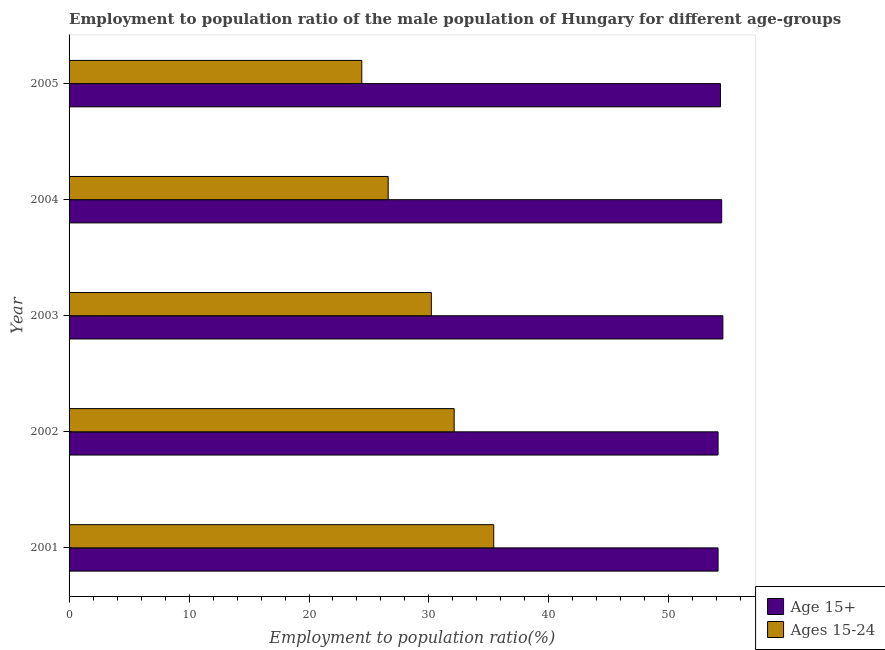How many groups of bars are there?
Make the answer very short. 5. Are the number of bars per tick equal to the number of legend labels?
Keep it short and to the point. Yes. Are the number of bars on each tick of the Y-axis equal?
Make the answer very short. Yes. How many bars are there on the 2nd tick from the top?
Your answer should be compact. 2. What is the label of the 2nd group of bars from the top?
Offer a terse response. 2004. In how many cases, is the number of bars for a given year not equal to the number of legend labels?
Your answer should be very brief. 0. What is the employment to population ratio(age 15-24) in 2004?
Provide a short and direct response. 26.6. Across all years, what is the maximum employment to population ratio(age 15+)?
Provide a succinct answer. 54.5. Across all years, what is the minimum employment to population ratio(age 15-24)?
Give a very brief answer. 24.4. In which year was the employment to population ratio(age 15+) maximum?
Offer a terse response. 2003. What is the total employment to population ratio(age 15+) in the graph?
Offer a terse response. 271.4. What is the difference between the employment to population ratio(age 15+) in 2002 and the employment to population ratio(age 15-24) in 2003?
Your response must be concise. 23.9. What is the average employment to population ratio(age 15-24) per year?
Keep it short and to the point. 29.74. In how many years, is the employment to population ratio(age 15-24) greater than 48 %?
Ensure brevity in your answer.  0. What is the ratio of the employment to population ratio(age 15+) in 2002 to that in 2004?
Provide a short and direct response. 0.99. Is the difference between the employment to population ratio(age 15+) in 2001 and 2004 greater than the difference between the employment to population ratio(age 15-24) in 2001 and 2004?
Keep it short and to the point. No. What is the difference between the highest and the second highest employment to population ratio(age 15+)?
Give a very brief answer. 0.1. What is the difference between the highest and the lowest employment to population ratio(age 15+)?
Offer a terse response. 0.4. In how many years, is the employment to population ratio(age 15-24) greater than the average employment to population ratio(age 15-24) taken over all years?
Offer a terse response. 3. What does the 2nd bar from the top in 2001 represents?
Give a very brief answer. Age 15+. What does the 2nd bar from the bottom in 2002 represents?
Your answer should be compact. Ages 15-24. How many bars are there?
Provide a short and direct response. 10. Are all the bars in the graph horizontal?
Your answer should be very brief. Yes. Where does the legend appear in the graph?
Make the answer very short. Bottom right. How are the legend labels stacked?
Offer a very short reply. Vertical. What is the title of the graph?
Ensure brevity in your answer.  Employment to population ratio of the male population of Hungary for different age-groups. Does "From human activities" appear as one of the legend labels in the graph?
Your answer should be very brief. No. What is the label or title of the X-axis?
Your answer should be very brief. Employment to population ratio(%). What is the Employment to population ratio(%) of Age 15+ in 2001?
Offer a terse response. 54.1. What is the Employment to population ratio(%) of Ages 15-24 in 2001?
Make the answer very short. 35.4. What is the Employment to population ratio(%) in Age 15+ in 2002?
Keep it short and to the point. 54.1. What is the Employment to population ratio(%) in Ages 15-24 in 2002?
Provide a succinct answer. 32.1. What is the Employment to population ratio(%) in Age 15+ in 2003?
Provide a short and direct response. 54.5. What is the Employment to population ratio(%) in Ages 15-24 in 2003?
Your answer should be compact. 30.2. What is the Employment to population ratio(%) of Age 15+ in 2004?
Provide a short and direct response. 54.4. What is the Employment to population ratio(%) of Ages 15-24 in 2004?
Provide a succinct answer. 26.6. What is the Employment to population ratio(%) of Age 15+ in 2005?
Give a very brief answer. 54.3. What is the Employment to population ratio(%) of Ages 15-24 in 2005?
Provide a short and direct response. 24.4. Across all years, what is the maximum Employment to population ratio(%) in Age 15+?
Your answer should be compact. 54.5. Across all years, what is the maximum Employment to population ratio(%) in Ages 15-24?
Your response must be concise. 35.4. Across all years, what is the minimum Employment to population ratio(%) in Age 15+?
Keep it short and to the point. 54.1. Across all years, what is the minimum Employment to population ratio(%) of Ages 15-24?
Offer a very short reply. 24.4. What is the total Employment to population ratio(%) of Age 15+ in the graph?
Ensure brevity in your answer.  271.4. What is the total Employment to population ratio(%) of Ages 15-24 in the graph?
Make the answer very short. 148.7. What is the difference between the Employment to population ratio(%) in Age 15+ in 2001 and that in 2002?
Provide a short and direct response. 0. What is the difference between the Employment to population ratio(%) of Age 15+ in 2001 and that in 2004?
Offer a very short reply. -0.3. What is the difference between the Employment to population ratio(%) in Ages 15-24 in 2001 and that in 2004?
Give a very brief answer. 8.8. What is the difference between the Employment to population ratio(%) in Age 15+ in 2002 and that in 2004?
Give a very brief answer. -0.3. What is the difference between the Employment to population ratio(%) in Ages 15-24 in 2002 and that in 2005?
Make the answer very short. 7.7. What is the difference between the Employment to population ratio(%) of Age 15+ in 2003 and that in 2004?
Provide a succinct answer. 0.1. What is the difference between the Employment to population ratio(%) of Ages 15-24 in 2003 and that in 2004?
Make the answer very short. 3.6. What is the difference between the Employment to population ratio(%) of Age 15+ in 2004 and that in 2005?
Offer a very short reply. 0.1. What is the difference between the Employment to population ratio(%) in Age 15+ in 2001 and the Employment to population ratio(%) in Ages 15-24 in 2002?
Your response must be concise. 22. What is the difference between the Employment to population ratio(%) in Age 15+ in 2001 and the Employment to population ratio(%) in Ages 15-24 in 2003?
Keep it short and to the point. 23.9. What is the difference between the Employment to population ratio(%) in Age 15+ in 2001 and the Employment to population ratio(%) in Ages 15-24 in 2004?
Provide a short and direct response. 27.5. What is the difference between the Employment to population ratio(%) in Age 15+ in 2001 and the Employment to population ratio(%) in Ages 15-24 in 2005?
Ensure brevity in your answer.  29.7. What is the difference between the Employment to population ratio(%) in Age 15+ in 2002 and the Employment to population ratio(%) in Ages 15-24 in 2003?
Your answer should be compact. 23.9. What is the difference between the Employment to population ratio(%) in Age 15+ in 2002 and the Employment to population ratio(%) in Ages 15-24 in 2005?
Provide a short and direct response. 29.7. What is the difference between the Employment to population ratio(%) of Age 15+ in 2003 and the Employment to population ratio(%) of Ages 15-24 in 2004?
Your answer should be very brief. 27.9. What is the difference between the Employment to population ratio(%) of Age 15+ in 2003 and the Employment to population ratio(%) of Ages 15-24 in 2005?
Provide a succinct answer. 30.1. What is the average Employment to population ratio(%) in Age 15+ per year?
Give a very brief answer. 54.28. What is the average Employment to population ratio(%) in Ages 15-24 per year?
Give a very brief answer. 29.74. In the year 2001, what is the difference between the Employment to population ratio(%) in Age 15+ and Employment to population ratio(%) in Ages 15-24?
Keep it short and to the point. 18.7. In the year 2003, what is the difference between the Employment to population ratio(%) in Age 15+ and Employment to population ratio(%) in Ages 15-24?
Your response must be concise. 24.3. In the year 2004, what is the difference between the Employment to population ratio(%) in Age 15+ and Employment to population ratio(%) in Ages 15-24?
Offer a very short reply. 27.8. In the year 2005, what is the difference between the Employment to population ratio(%) in Age 15+ and Employment to population ratio(%) in Ages 15-24?
Offer a very short reply. 29.9. What is the ratio of the Employment to population ratio(%) of Ages 15-24 in 2001 to that in 2002?
Offer a very short reply. 1.1. What is the ratio of the Employment to population ratio(%) in Ages 15-24 in 2001 to that in 2003?
Your response must be concise. 1.17. What is the ratio of the Employment to population ratio(%) in Age 15+ in 2001 to that in 2004?
Offer a very short reply. 0.99. What is the ratio of the Employment to population ratio(%) in Ages 15-24 in 2001 to that in 2004?
Offer a terse response. 1.33. What is the ratio of the Employment to population ratio(%) of Age 15+ in 2001 to that in 2005?
Ensure brevity in your answer.  1. What is the ratio of the Employment to population ratio(%) of Ages 15-24 in 2001 to that in 2005?
Offer a very short reply. 1.45. What is the ratio of the Employment to population ratio(%) of Age 15+ in 2002 to that in 2003?
Provide a succinct answer. 0.99. What is the ratio of the Employment to population ratio(%) of Ages 15-24 in 2002 to that in 2003?
Offer a terse response. 1.06. What is the ratio of the Employment to population ratio(%) in Age 15+ in 2002 to that in 2004?
Give a very brief answer. 0.99. What is the ratio of the Employment to population ratio(%) of Ages 15-24 in 2002 to that in 2004?
Ensure brevity in your answer.  1.21. What is the ratio of the Employment to population ratio(%) in Ages 15-24 in 2002 to that in 2005?
Offer a terse response. 1.32. What is the ratio of the Employment to population ratio(%) in Ages 15-24 in 2003 to that in 2004?
Your answer should be compact. 1.14. What is the ratio of the Employment to population ratio(%) of Ages 15-24 in 2003 to that in 2005?
Offer a very short reply. 1.24. What is the ratio of the Employment to population ratio(%) in Age 15+ in 2004 to that in 2005?
Offer a very short reply. 1. What is the ratio of the Employment to population ratio(%) in Ages 15-24 in 2004 to that in 2005?
Make the answer very short. 1.09. What is the difference between the highest and the second highest Employment to population ratio(%) in Ages 15-24?
Ensure brevity in your answer.  3.3. What is the difference between the highest and the lowest Employment to population ratio(%) of Age 15+?
Your answer should be very brief. 0.4. What is the difference between the highest and the lowest Employment to population ratio(%) of Ages 15-24?
Offer a terse response. 11. 